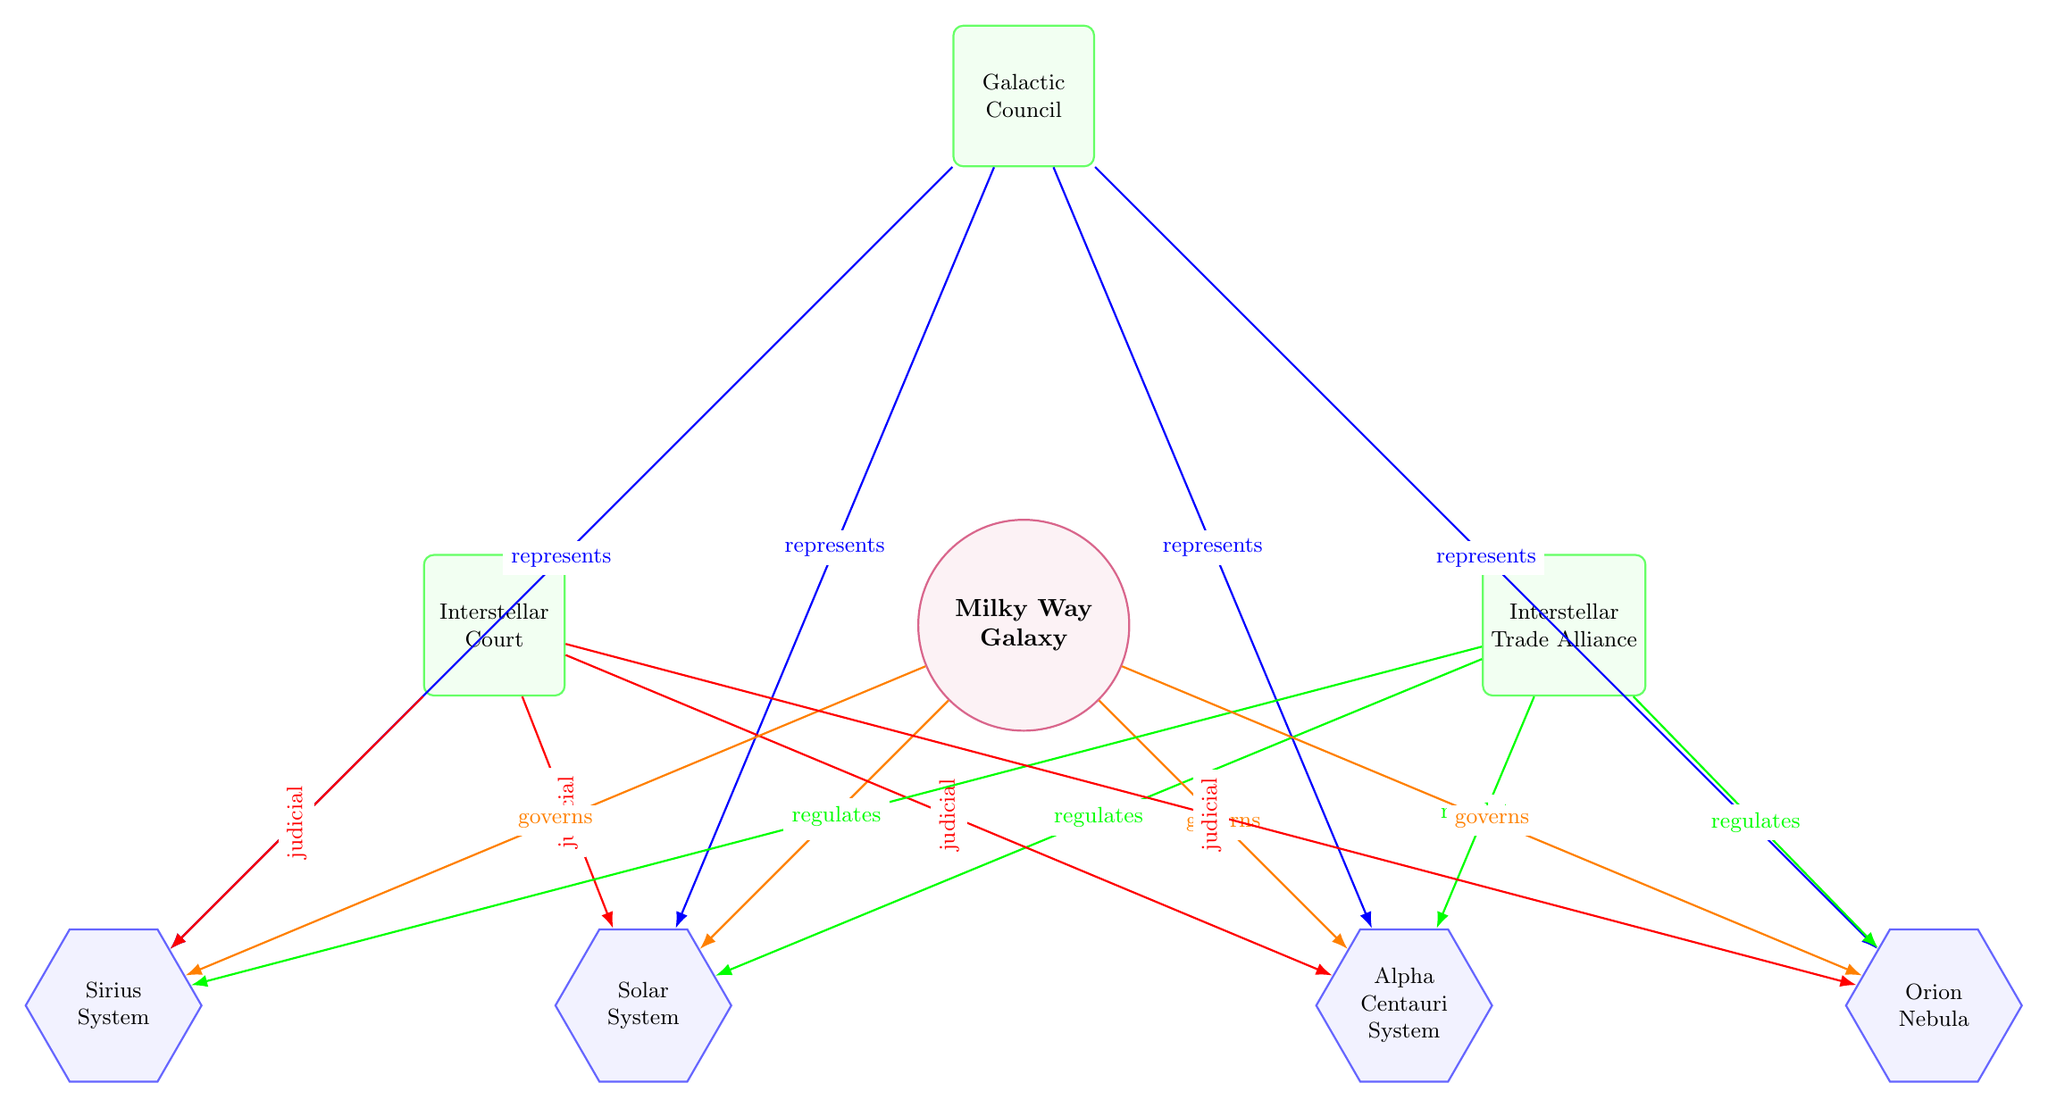What is the central governing body in the diagram? The central governing body is clearly labeled at the top of the diagram, identified as the Milky Way Galaxy. This is represented in a circular node that stands out as central to the other nodes.
Answer: Milky Way Galaxy How many federated entities are depicted? To determine this, we count the nodes classified as 'federated' which are arranged under the central Milky Way Galaxy. There are four such nodes: Solar System, Alpha Centauri System, Sirius System, and Orion Nebula.
Answer: 4 Which body is responsible for regulation? In the diagram, the body that oversees regulations is represented using a green rectangle labeled 'Interstellar Trade Alliance.' This node connects with all the federated entities, indicating its regulatory role.
Answer: Interstellar Trade Alliance What type of edges connect the central Milky Way Galaxy to the federated entities? There are edges connecting the central node to each federated entity with a specific label that points to their governance relationship. These edges are colored orange and denote the governing relationship between the central body and the federated nodes.
Answer: Governs (orange edges) Which federated entity is directly linked to the Orion Nebula? By observing the connections, we see that the node labeled 'Orion Nebula' is positioned to the right of the Alpha Centauri System. This indicates that the direct link to the Orion Nebula is from the higher central node.
Answer: Milky Way Galaxy What is the judicial body in the diagram? The judicial body is shown to the left of the Milky Way Galaxy and is labeled as 'Interstellar Court.' This designation confirms its role as the judicial authority in the galactic structure.
Answer: Interstellar Court Which federated entity is closest to the Solar System? The arrangement of the nodes shows that the Sirius System is positioned directly to the left of the Solar System, making it the closest entity to it in the diagram's layout.
Answer: Sirius System What relationship does the Galactic Council have with the federated entities? The Galactic Council is represented by blue edges that connect it to each federated entity, indicating that it represents those entities in the broader governance structure established within the diagram.
Answer: Represents (blue edges) 